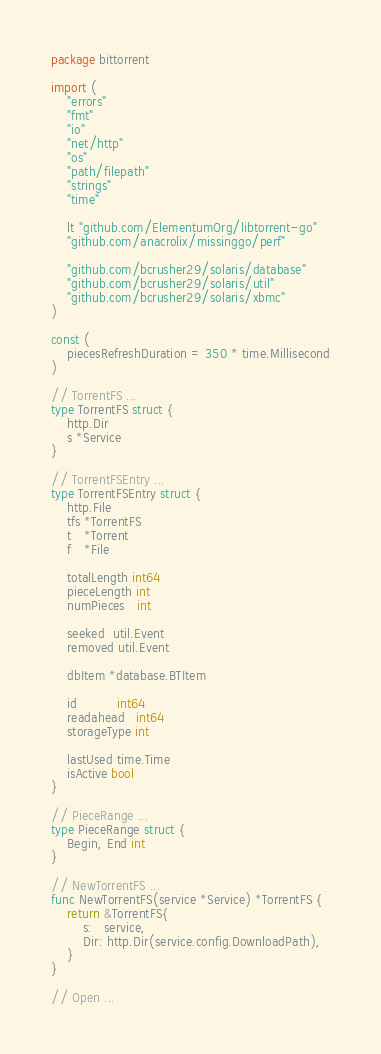Convert code to text. <code><loc_0><loc_0><loc_500><loc_500><_Go_>package bittorrent

import (
	"errors"
	"fmt"
	"io"
	"net/http"
	"os"
	"path/filepath"
	"strings"
	"time"

	lt "github.com/ElementumOrg/libtorrent-go"
	"github.com/anacrolix/missinggo/perf"

	"github.com/bcrusher29/solaris/database"
	"github.com/bcrusher29/solaris/util"
	"github.com/bcrusher29/solaris/xbmc"
)

const (
	piecesRefreshDuration = 350 * time.Millisecond
)

// TorrentFS ...
type TorrentFS struct {
	http.Dir
	s *Service
}

// TorrentFSEntry ...
type TorrentFSEntry struct {
	http.File
	tfs *TorrentFS
	t   *Torrent
	f   *File

	totalLength int64
	pieceLength int
	numPieces   int

	seeked  util.Event
	removed util.Event

	dbItem *database.BTItem

	id          int64
	readahead   int64
	storageType int

	lastUsed time.Time
	isActive bool
}

// PieceRange ...
type PieceRange struct {
	Begin, End int
}

// NewTorrentFS ...
func NewTorrentFS(service *Service) *TorrentFS {
	return &TorrentFS{
		s:   service,
		Dir: http.Dir(service.config.DownloadPath),
	}
}

// Open ...</code> 